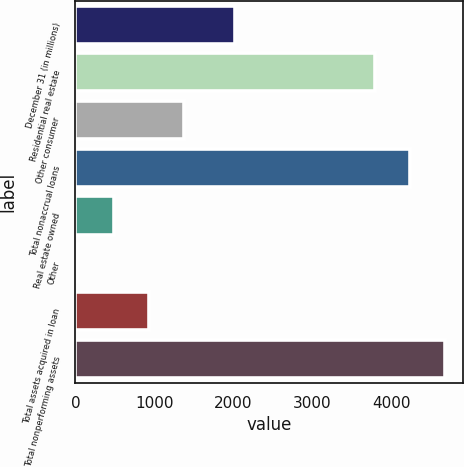Convert chart. <chart><loc_0><loc_0><loc_500><loc_500><bar_chart><fcel>December 31 (in millions)<fcel>Residential real estate<fcel>Other consumer<fcel>Total nonaccrual loans<fcel>Real estate owned<fcel>Other<fcel>Total assets acquired in loan<fcel>Total nonperforming assets<nl><fcel>2017<fcel>3785<fcel>1370.2<fcel>4228.4<fcel>483.4<fcel>40<fcel>926.8<fcel>4671.8<nl></chart> 